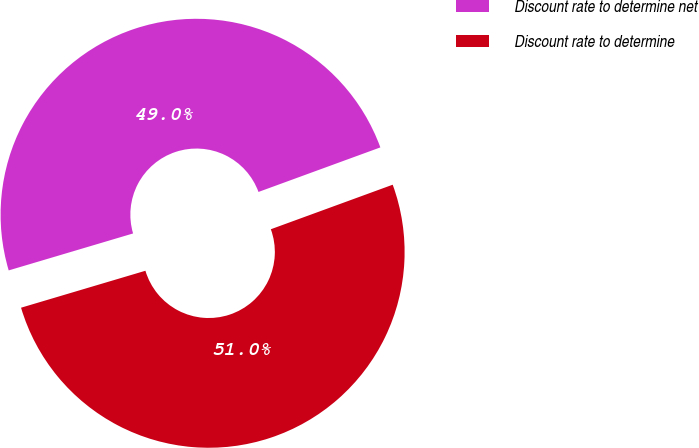<chart> <loc_0><loc_0><loc_500><loc_500><pie_chart><fcel>Discount rate to determine net<fcel>Discount rate to determine<nl><fcel>49.02%<fcel>50.98%<nl></chart> 